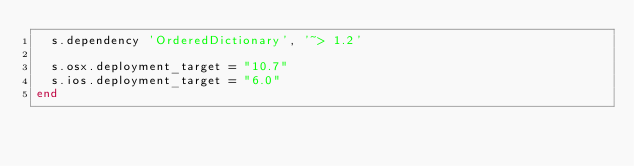<code> <loc_0><loc_0><loc_500><loc_500><_Ruby_>  s.dependency 'OrderedDictionary', '~> 1.2'

  s.osx.deployment_target = "10.7"
  s.ios.deployment_target = "6.0"
end
</code> 